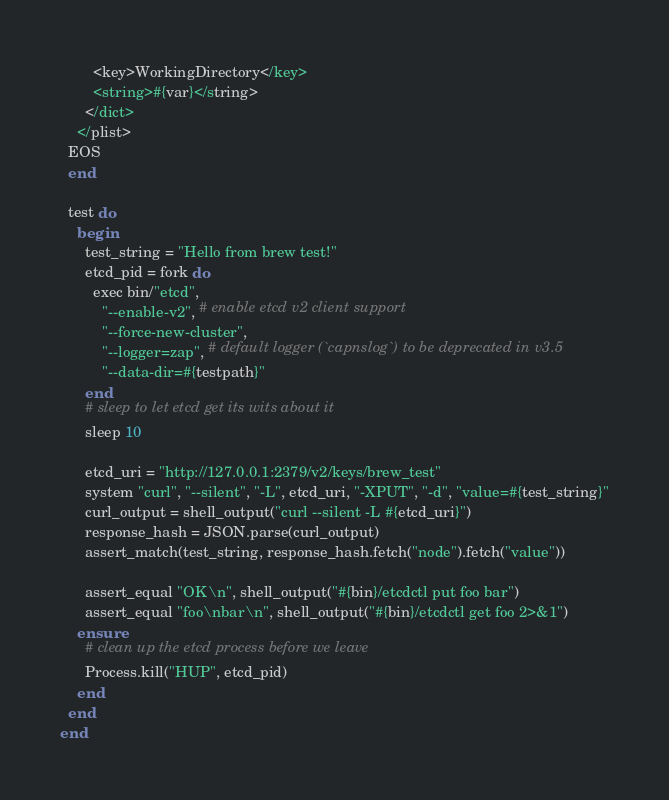Convert code to text. <code><loc_0><loc_0><loc_500><loc_500><_Ruby_>        <key>WorkingDirectory</key>
        <string>#{var}</string>
      </dict>
    </plist>
  EOS
  end

  test do
    begin
      test_string = "Hello from brew test!"
      etcd_pid = fork do
        exec bin/"etcd",
          "--enable-v2", # enable etcd v2 client support
          "--force-new-cluster",
          "--logger=zap", # default logger (`capnslog`) to be deprecated in v3.5
          "--data-dir=#{testpath}"
      end
      # sleep to let etcd get its wits about it
      sleep 10

      etcd_uri = "http://127.0.0.1:2379/v2/keys/brew_test"
      system "curl", "--silent", "-L", etcd_uri, "-XPUT", "-d", "value=#{test_string}"
      curl_output = shell_output("curl --silent -L #{etcd_uri}")
      response_hash = JSON.parse(curl_output)
      assert_match(test_string, response_hash.fetch("node").fetch("value"))

      assert_equal "OK\n", shell_output("#{bin}/etcdctl put foo bar")
      assert_equal "foo\nbar\n", shell_output("#{bin}/etcdctl get foo 2>&1")
    ensure
      # clean up the etcd process before we leave
      Process.kill("HUP", etcd_pid)
    end
  end
end
</code> 